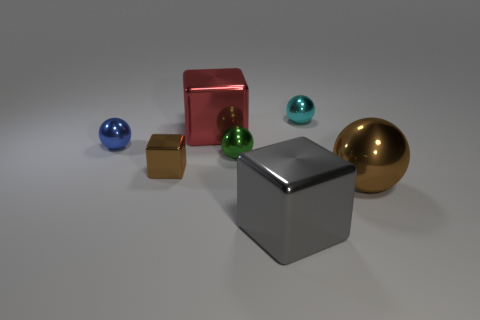Subtract all big red metallic blocks. How many blocks are left? 2 Subtract all cyan balls. How many balls are left? 3 Subtract all green blocks. Subtract all green balls. How many blocks are left? 3 Subtract all purple cylinders. How many gray blocks are left? 1 Add 1 green shiny cubes. How many objects exist? 8 Subtract 0 yellow spheres. How many objects are left? 7 Subtract all balls. How many objects are left? 3 Subtract all brown cubes. Subtract all big red objects. How many objects are left? 5 Add 2 cyan objects. How many cyan objects are left? 3 Add 4 small matte spheres. How many small matte spheres exist? 4 